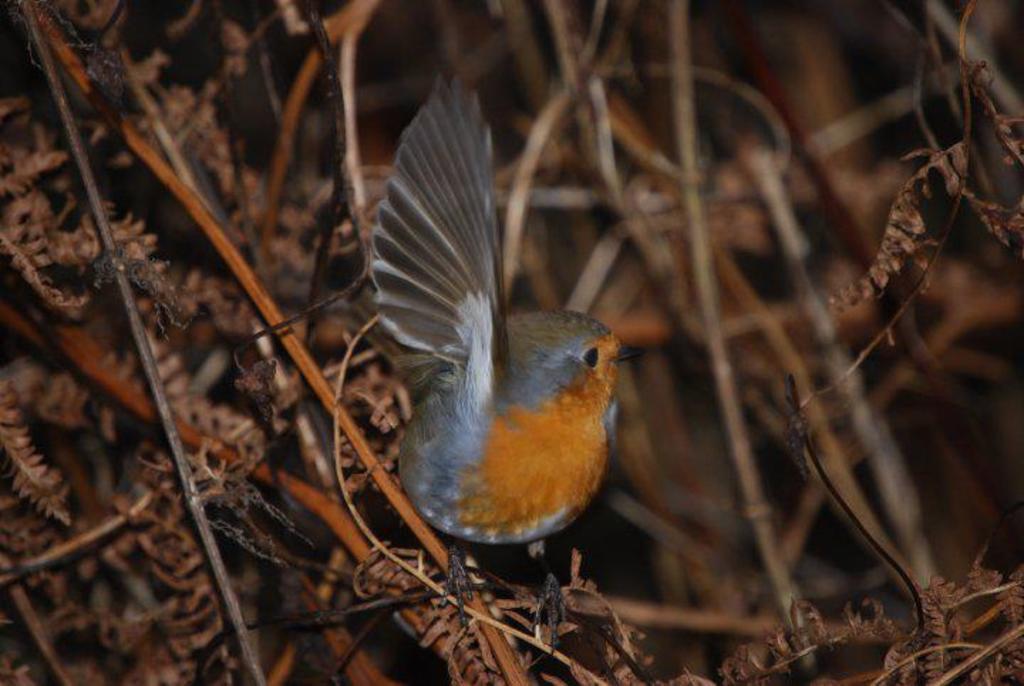Could you give a brief overview of what you see in this image? In this image I can see a bird which is orange, brown, grey, white and black in color is on a plant which is brown and orange in color. I can see the blurry background. 